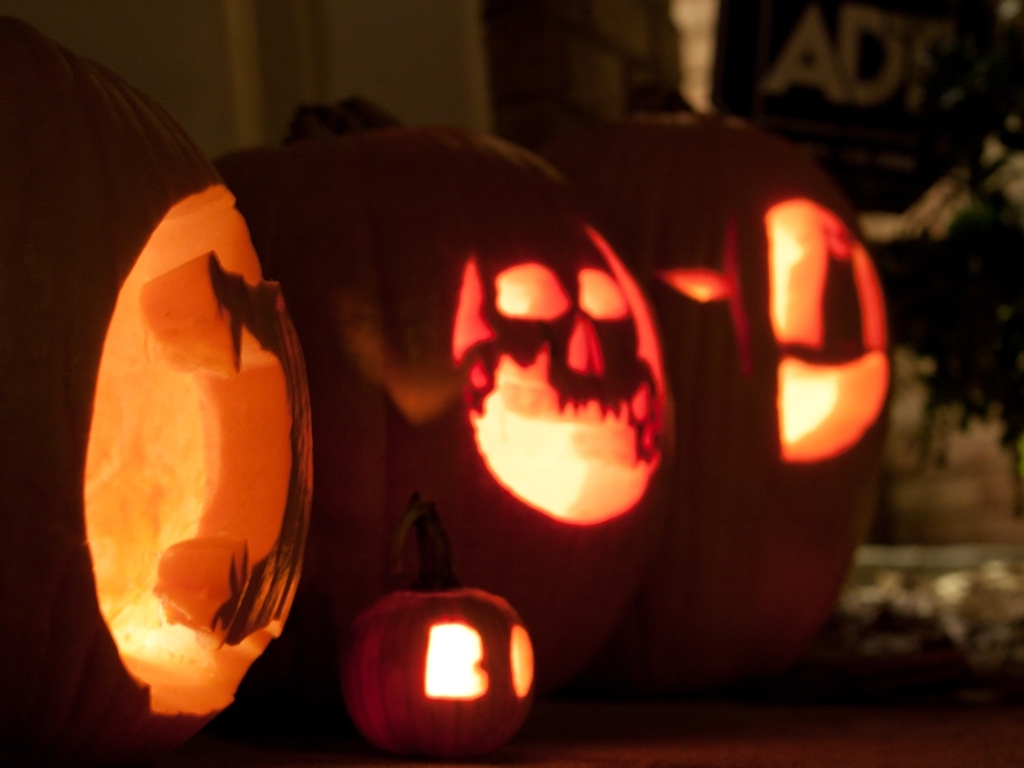What enhancements can be applied to improve the overall quality of this image while maintaining its eerie atmosphere? Improving the image quality could involve slightly increasing the exposure to reveal more detail without washing out the scene. Adding a subtle sharpen filter could enhance the details of the pumpkin textures. Adjusting contrast might balance the very bright and very dark areas, ensuring the eerie atmosphere is maintained while enhancing overall visibility. 